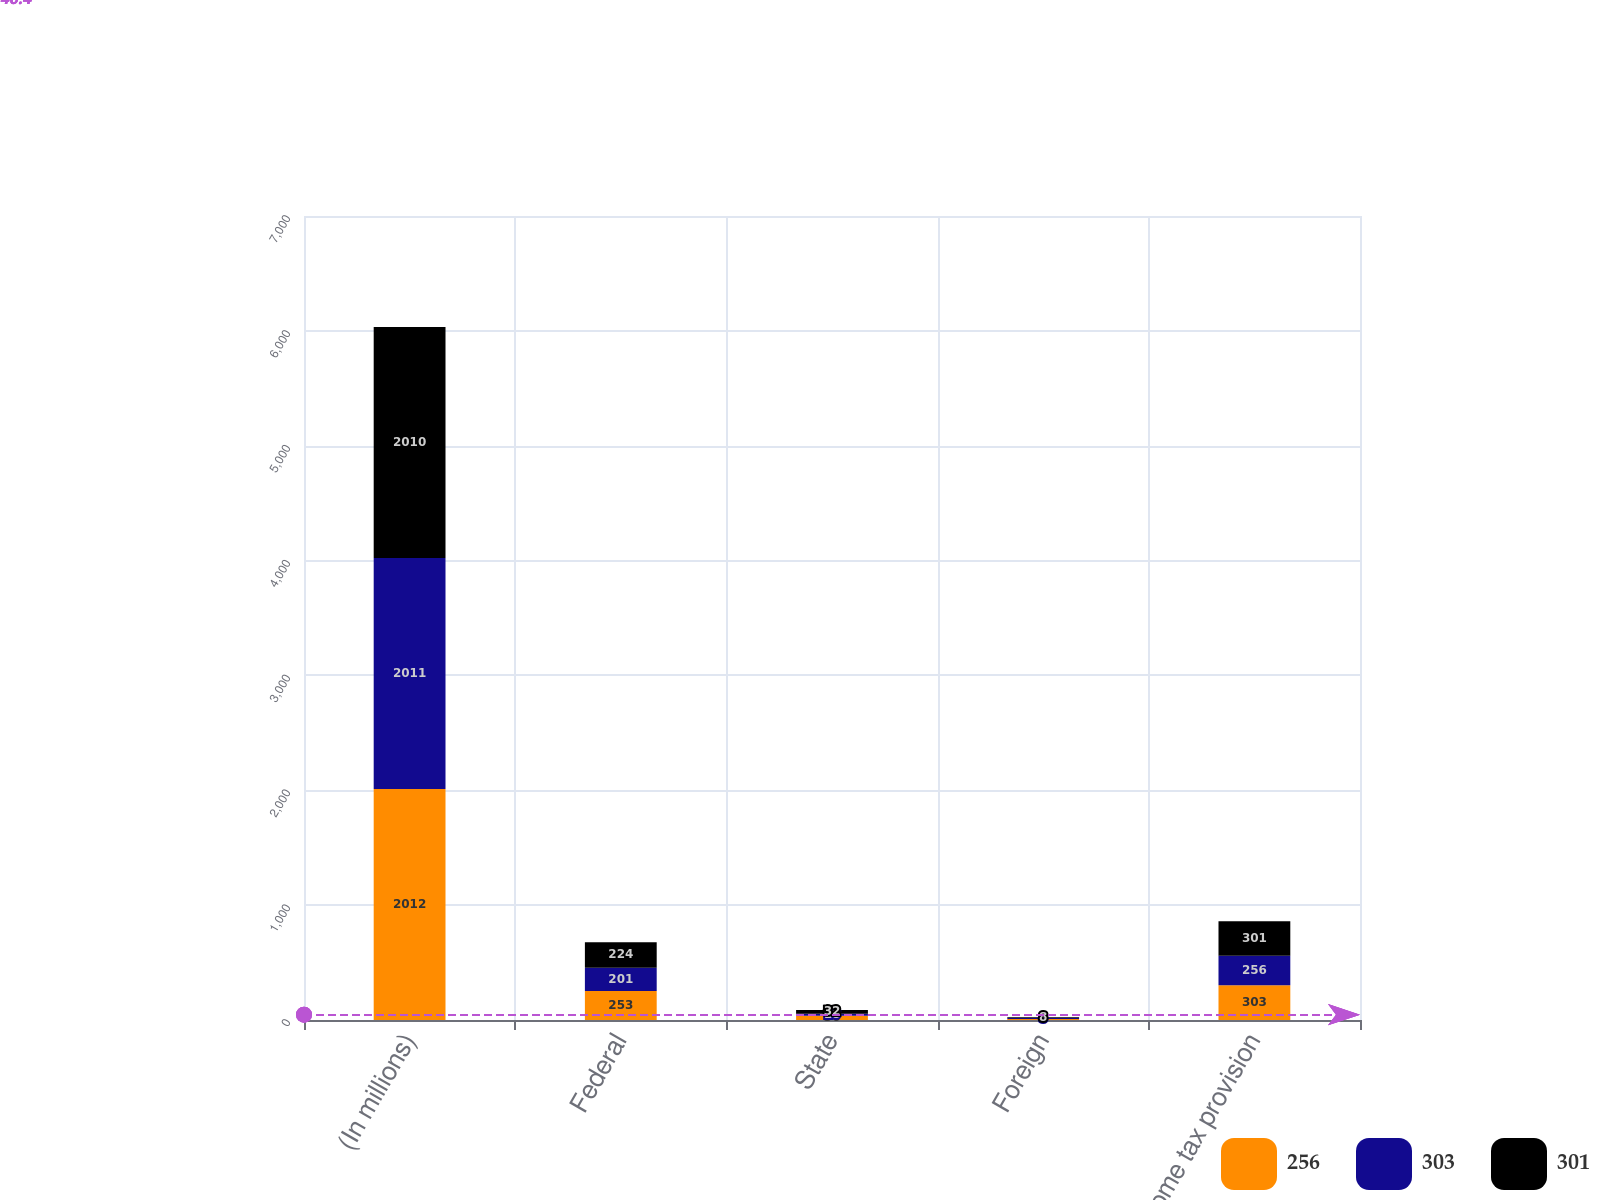Convert chart. <chart><loc_0><loc_0><loc_500><loc_500><stacked_bar_chart><ecel><fcel>(In millions)<fcel>Federal<fcel>State<fcel>Foreign<fcel>Income tax provision<nl><fcel>256<fcel>2012<fcel>253<fcel>36<fcel>9<fcel>303<nl><fcel>303<fcel>2011<fcel>201<fcel>18<fcel>8<fcel>256<nl><fcel>301<fcel>2010<fcel>224<fcel>32<fcel>8<fcel>301<nl></chart> 